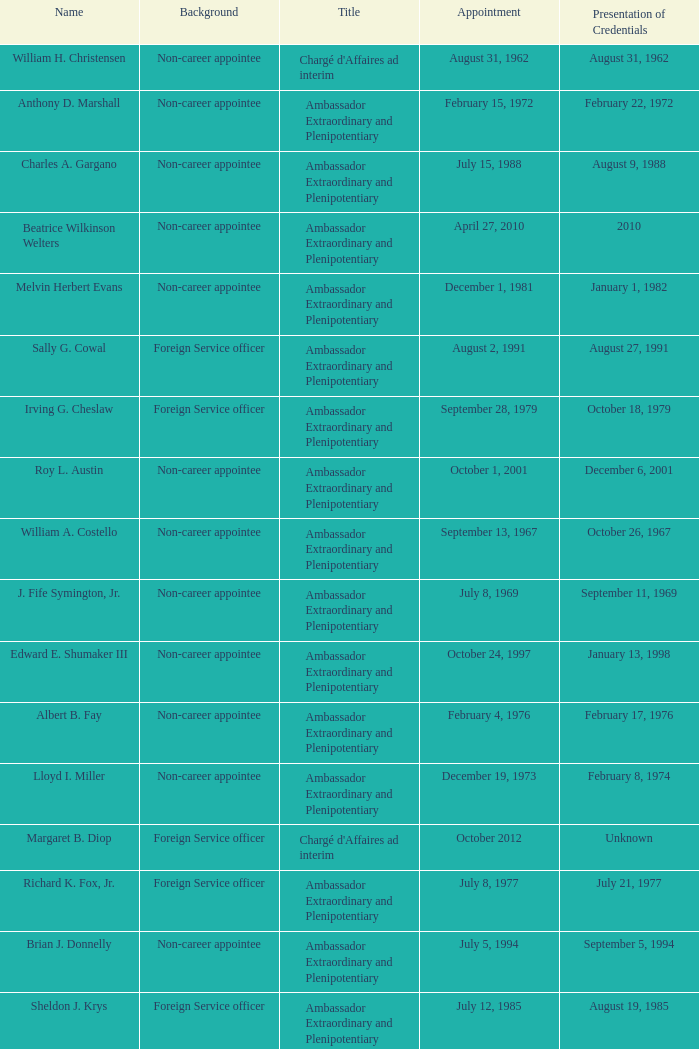When did robert g. miner submit his qualifications? December 1, 1962. 